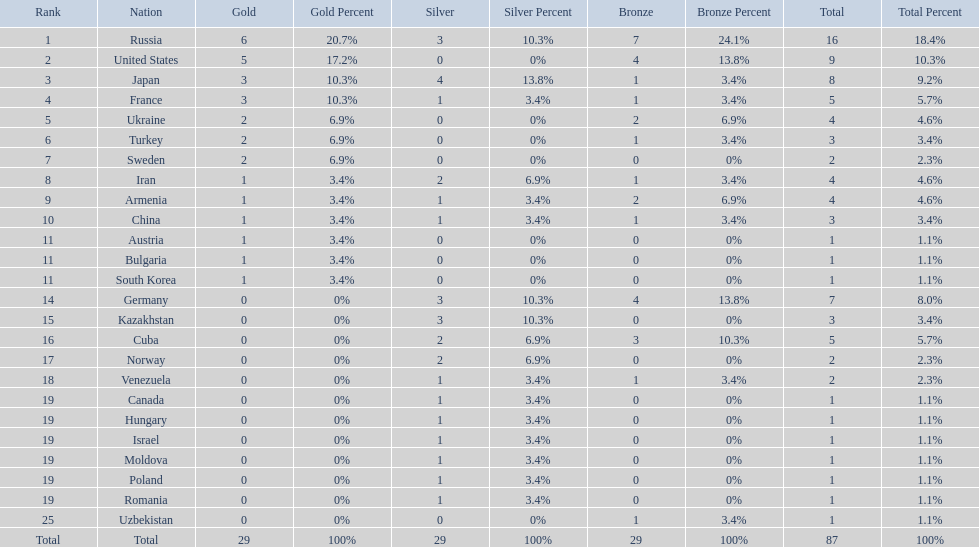What was iran's ranking? 8. What was germany's ranking? 14. Between iran and germany, which was not in the top 10? Germany. 